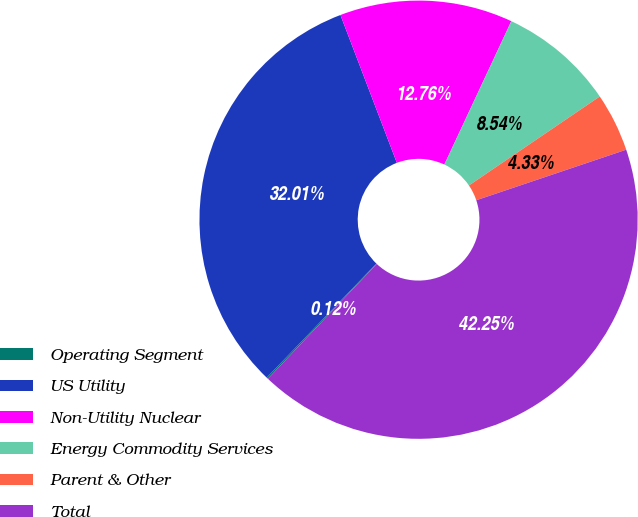Convert chart to OTSL. <chart><loc_0><loc_0><loc_500><loc_500><pie_chart><fcel>Operating Segment<fcel>US Utility<fcel>Non-Utility Nuclear<fcel>Energy Commodity Services<fcel>Parent & Other<fcel>Total<nl><fcel>0.12%<fcel>32.01%<fcel>12.76%<fcel>8.54%<fcel>4.33%<fcel>42.25%<nl></chart> 